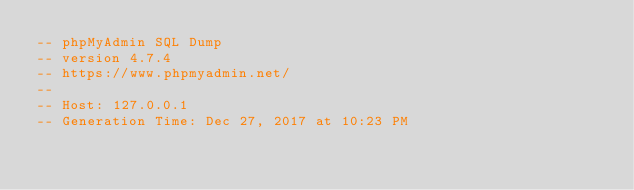Convert code to text. <code><loc_0><loc_0><loc_500><loc_500><_SQL_>-- phpMyAdmin SQL Dump
-- version 4.7.4
-- https://www.phpmyadmin.net/
--
-- Host: 127.0.0.1
-- Generation Time: Dec 27, 2017 at 10:23 PM</code> 